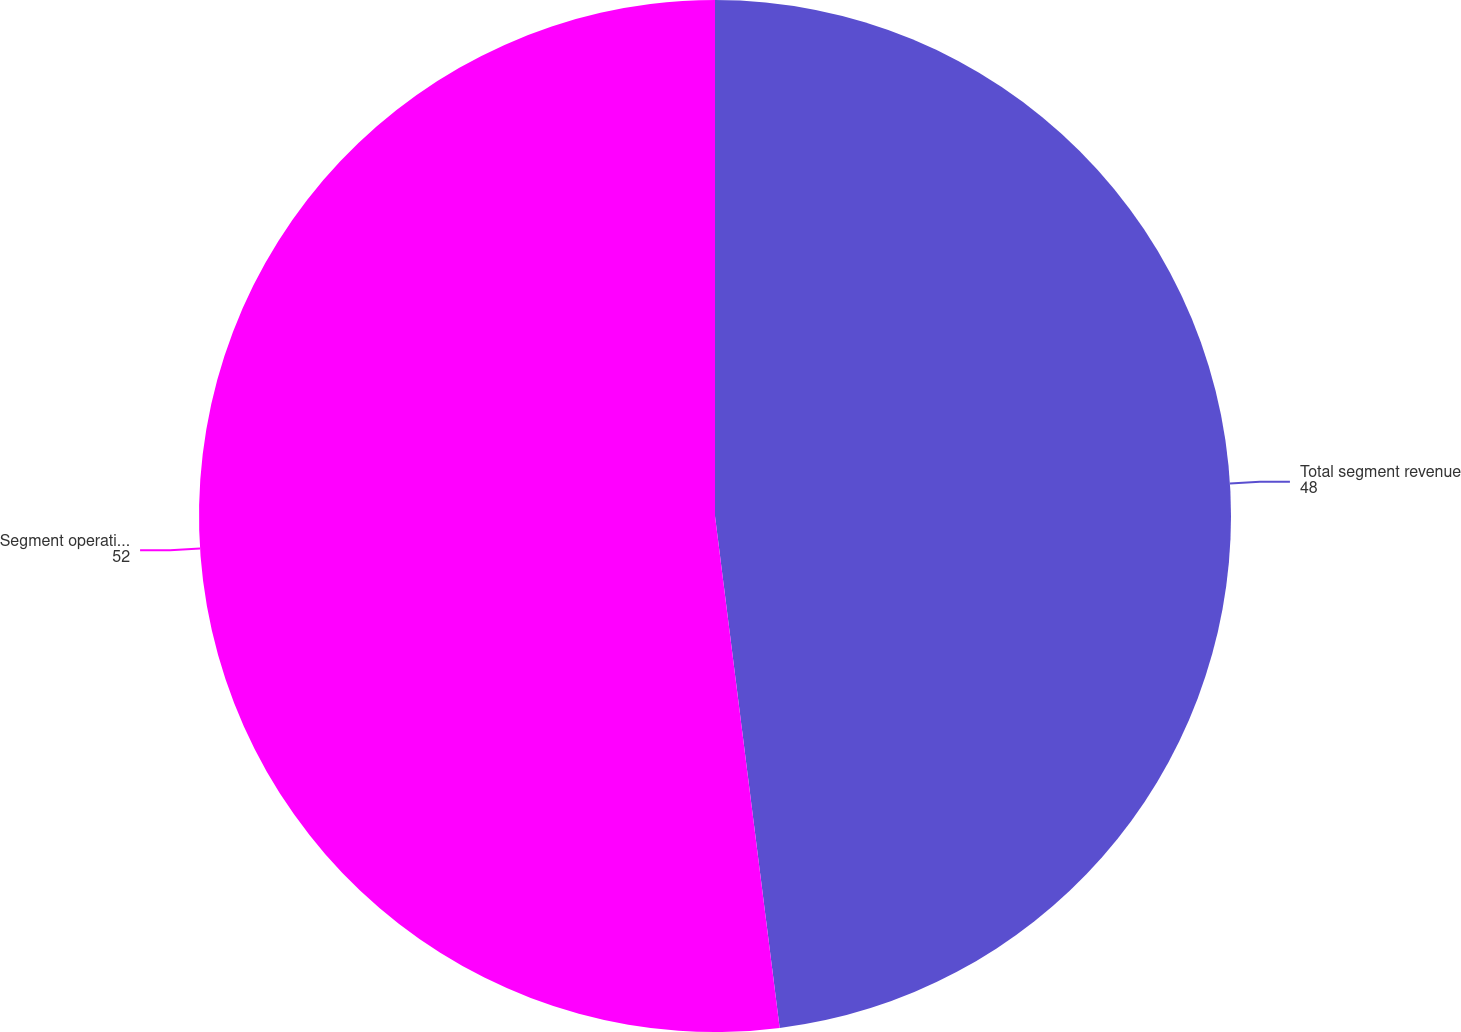Convert chart. <chart><loc_0><loc_0><loc_500><loc_500><pie_chart><fcel>Total segment revenue<fcel>Segment operating income<nl><fcel>48.0%<fcel>52.0%<nl></chart> 